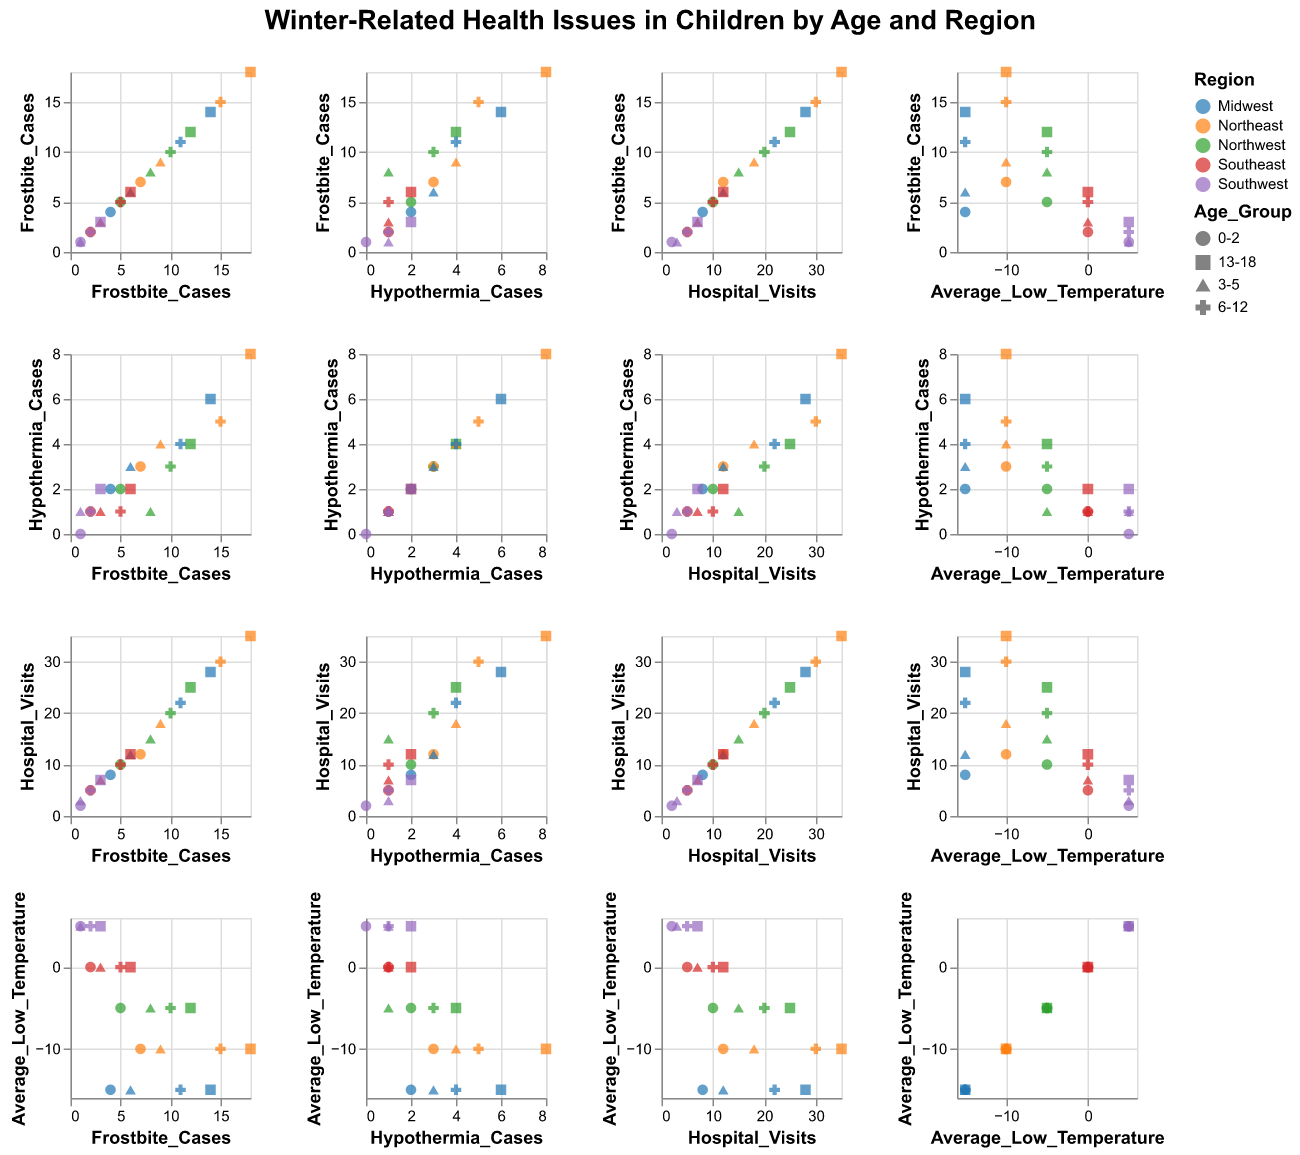What is the title of the figure? The figure's title is prominently displayed at the top of the plot.
Answer: Winter-Related Health Issues in Children by Age and Region Which region has the highest number of hospital visits for the age group 13-18? To find this, locate the hospital visits values for the age group 13-18 across all regions and compare.
Answer: Northeast What is the relationship between average low temperature and frostbite cases in the Northeast region? Look at the plot for average low temperature and frostbite cases, and focus on the points with the color corresponding to the Northeast region. There should be a visual trend, most likely positive.
Answer: Positive correlation How do hypothermia cases vary across different age groups in the Midwest region? Check the plot for hypothermia cases versus age groups and focus on the data points in the Midwest region. Compare the values for different age groups.
Answer: They increase with age What's the difference in frostbite cases between the regions with the lowest and highest average low temperatures? Identify the regions with the lowest and highest average low temperatures and subtract their frostbite case values.
Answer: 17 (Midwest has 15 frostbite cases and Southwest has 3) Which age group appears to have the most hospital visits across all regions? Look at the hospital visit counts differentiated by age groups and find the highest count regardless of region.
Answer: 13-18 In which region and age group is the lowest number of hypothermia cases recorded? Find the lowest value in the hypothermia cases column and identify the corresponding region and age group.
Answer: Southwest, 0-2 Compare the number of hospital visits in the Southeast and Northwest regions for the age group 6-12. Which region has more? Look at the hospital visits for the age group 6-12 in Southeast and Northwest, then compare the numbers.
Answer: Northwest Is there any age group that shows zero frostbite cases across all regions? Look at the frostbite cases for each age group across all regions to determine if any age group has zero cases in each region.
Answer: No 